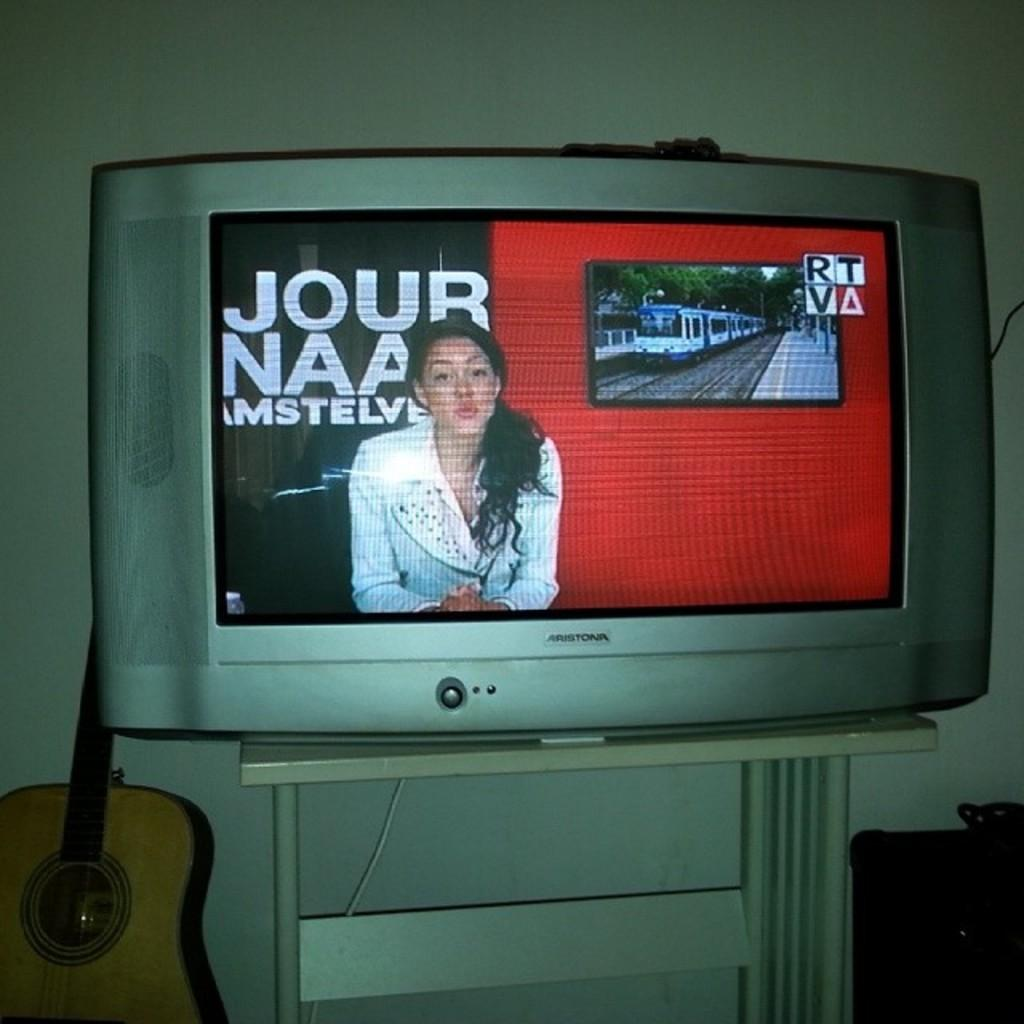<image>
Create a compact narrative representing the image presented. a lady talking on tv with a Jour sign behind her 